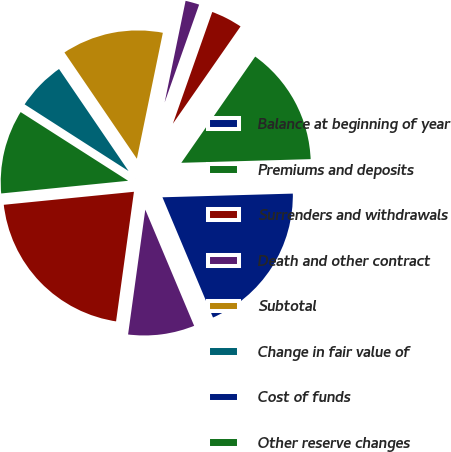Convert chart to OTSL. <chart><loc_0><loc_0><loc_500><loc_500><pie_chart><fcel>Balance at beginning of year<fcel>Premiums and deposits<fcel>Surrenders and withdrawals<fcel>Death and other contract<fcel>Subtotal<fcel>Change in fair value of<fcel>Cost of funds<fcel>Other reserve changes<fcel>Balance at end of year<fcel>Reinsurance ceded<nl><fcel>19.12%<fcel>14.88%<fcel>4.28%<fcel>2.16%<fcel>12.76%<fcel>6.4%<fcel>0.03%<fcel>10.64%<fcel>21.24%<fcel>8.52%<nl></chart> 